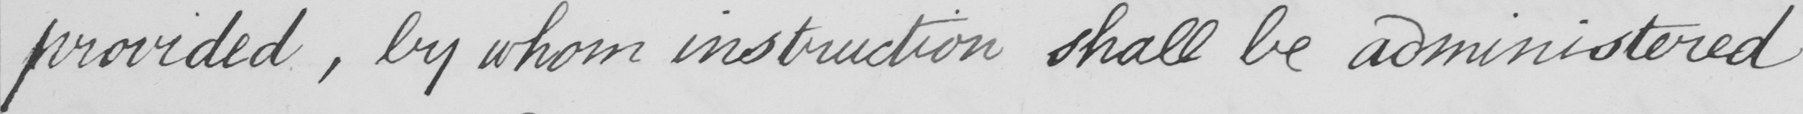Can you tell me what this handwritten text says? provided  , by whom instruction shall be administered 